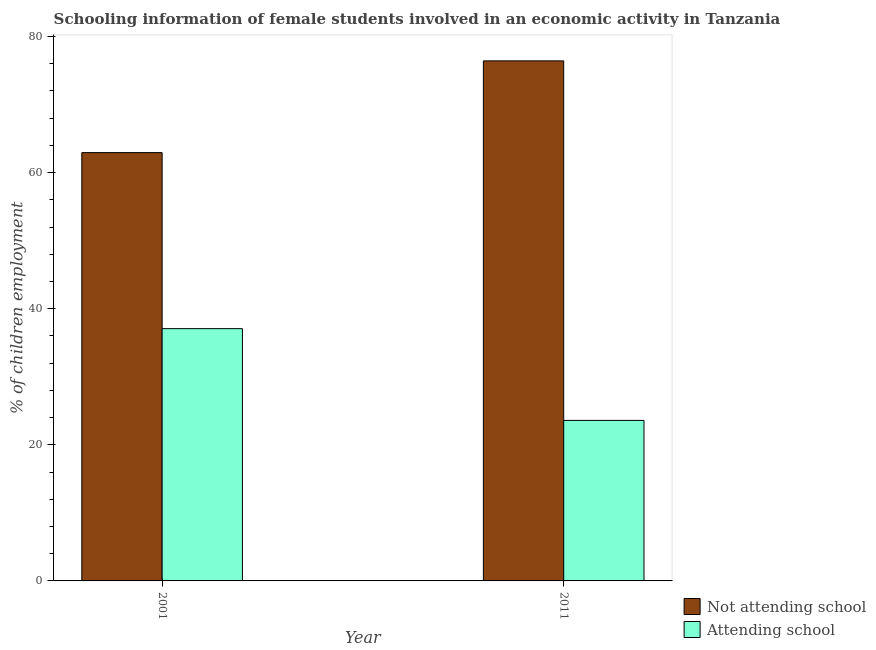How many groups of bars are there?
Offer a very short reply. 2. How many bars are there on the 1st tick from the right?
Offer a terse response. 2. What is the label of the 1st group of bars from the left?
Offer a very short reply. 2001. What is the percentage of employed females who are attending school in 2001?
Give a very brief answer. 37.07. Across all years, what is the maximum percentage of employed females who are attending school?
Ensure brevity in your answer.  37.07. Across all years, what is the minimum percentage of employed females who are attending school?
Ensure brevity in your answer.  23.59. In which year was the percentage of employed females who are attending school maximum?
Give a very brief answer. 2001. What is the total percentage of employed females who are not attending school in the graph?
Your answer should be compact. 139.35. What is the difference between the percentage of employed females who are not attending school in 2001 and that in 2011?
Your answer should be very brief. -13.48. What is the difference between the percentage of employed females who are not attending school in 2011 and the percentage of employed females who are attending school in 2001?
Make the answer very short. 13.48. What is the average percentage of employed females who are not attending school per year?
Provide a short and direct response. 69.67. What is the ratio of the percentage of employed females who are not attending school in 2001 to that in 2011?
Provide a succinct answer. 0.82. Is the percentage of employed females who are attending school in 2001 less than that in 2011?
Your answer should be very brief. No. In how many years, is the percentage of employed females who are not attending school greater than the average percentage of employed females who are not attending school taken over all years?
Your answer should be very brief. 1. What does the 1st bar from the left in 2001 represents?
Your answer should be compact. Not attending school. What does the 1st bar from the right in 2001 represents?
Keep it short and to the point. Attending school. How many bars are there?
Your answer should be very brief. 4. Are all the bars in the graph horizontal?
Your answer should be very brief. No. Are the values on the major ticks of Y-axis written in scientific E-notation?
Your answer should be compact. No. Does the graph contain any zero values?
Give a very brief answer. No. Does the graph contain grids?
Provide a short and direct response. No. Where does the legend appear in the graph?
Keep it short and to the point. Bottom right. What is the title of the graph?
Keep it short and to the point. Schooling information of female students involved in an economic activity in Tanzania. Does "IMF nonconcessional" appear as one of the legend labels in the graph?
Provide a succinct answer. No. What is the label or title of the X-axis?
Offer a very short reply. Year. What is the label or title of the Y-axis?
Provide a short and direct response. % of children employment. What is the % of children employment of Not attending school in 2001?
Keep it short and to the point. 62.93. What is the % of children employment in Attending school in 2001?
Make the answer very short. 37.07. What is the % of children employment of Not attending school in 2011?
Ensure brevity in your answer.  76.41. What is the % of children employment of Attending school in 2011?
Give a very brief answer. 23.59. Across all years, what is the maximum % of children employment of Not attending school?
Keep it short and to the point. 76.41. Across all years, what is the maximum % of children employment of Attending school?
Your answer should be very brief. 37.07. Across all years, what is the minimum % of children employment in Not attending school?
Your answer should be compact. 62.93. Across all years, what is the minimum % of children employment of Attending school?
Keep it short and to the point. 23.59. What is the total % of children employment of Not attending school in the graph?
Your response must be concise. 139.35. What is the total % of children employment in Attending school in the graph?
Provide a succinct answer. 60.65. What is the difference between the % of children employment of Not attending school in 2001 and that in 2011?
Ensure brevity in your answer.  -13.48. What is the difference between the % of children employment of Attending school in 2001 and that in 2011?
Offer a terse response. 13.48. What is the difference between the % of children employment of Not attending school in 2001 and the % of children employment of Attending school in 2011?
Offer a very short reply. 39.35. What is the average % of children employment of Not attending school per year?
Offer a terse response. 69.67. What is the average % of children employment in Attending school per year?
Ensure brevity in your answer.  30.33. In the year 2001, what is the difference between the % of children employment in Not attending school and % of children employment in Attending school?
Give a very brief answer. 25.87. In the year 2011, what is the difference between the % of children employment of Not attending school and % of children employment of Attending school?
Make the answer very short. 52.83. What is the ratio of the % of children employment of Not attending school in 2001 to that in 2011?
Offer a terse response. 0.82. What is the ratio of the % of children employment in Attending school in 2001 to that in 2011?
Your response must be concise. 1.57. What is the difference between the highest and the second highest % of children employment of Not attending school?
Give a very brief answer. 13.48. What is the difference between the highest and the second highest % of children employment of Attending school?
Give a very brief answer. 13.48. What is the difference between the highest and the lowest % of children employment in Not attending school?
Offer a very short reply. 13.48. What is the difference between the highest and the lowest % of children employment in Attending school?
Your answer should be very brief. 13.48. 